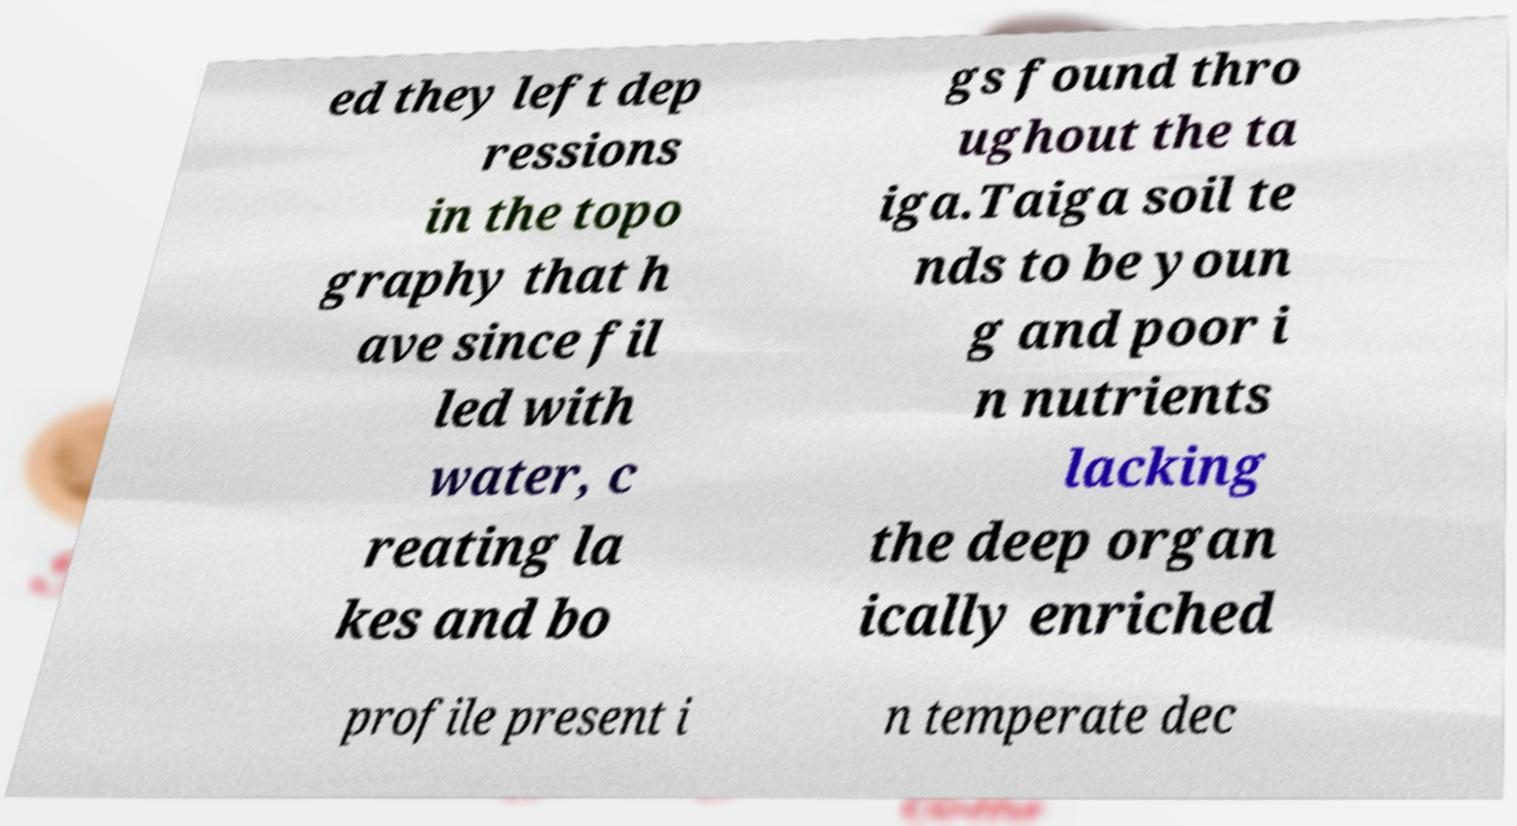Please identify and transcribe the text found in this image. ed they left dep ressions in the topo graphy that h ave since fil led with water, c reating la kes and bo gs found thro ughout the ta iga.Taiga soil te nds to be youn g and poor i n nutrients lacking the deep organ ically enriched profile present i n temperate dec 